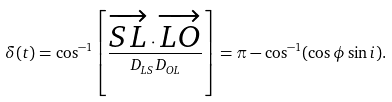<formula> <loc_0><loc_0><loc_500><loc_500>\delta ( t ) = \cos ^ { - 1 } \left [ \frac { \overrightarrow { S L } \cdot \overrightarrow { L O } } { D _ { L S } D _ { O L } } \right ] = \pi - \cos ^ { - 1 } ( \cos \phi \sin i ) .</formula> 